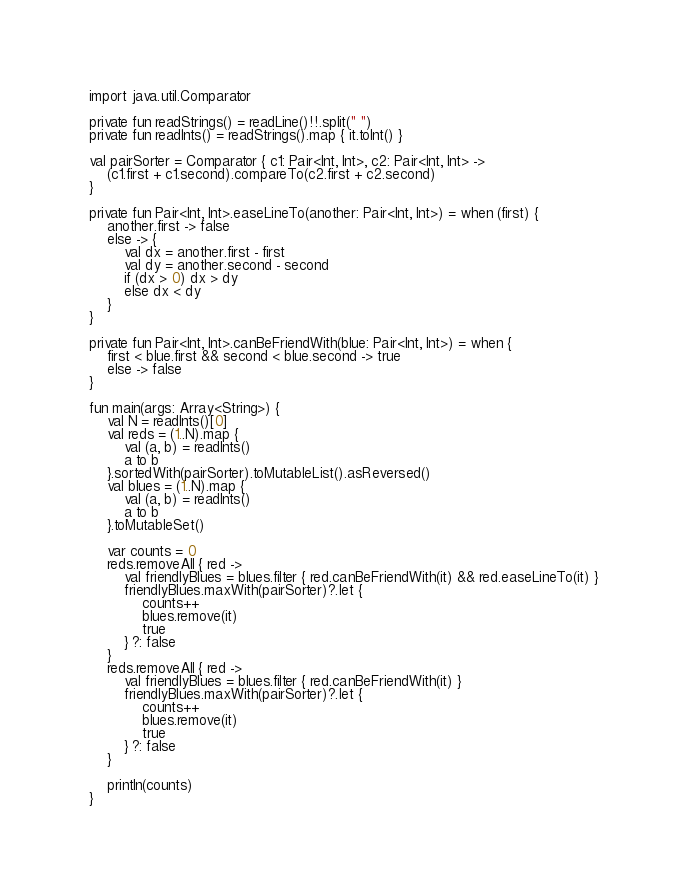Convert code to text. <code><loc_0><loc_0><loc_500><loc_500><_Kotlin_>import java.util.Comparator

private fun readStrings() = readLine()!!.split(" ")
private fun readInts() = readStrings().map { it.toInt() }

val pairSorter = Comparator { c1: Pair<Int, Int>, c2: Pair<Int, Int> ->
    (c1.first + c1.second).compareTo(c2.first + c2.second)
}

private fun Pair<Int, Int>.easeLineTo(another: Pair<Int, Int>) = when (first) {
    another.first -> false
    else -> {
        val dx = another.first - first
        val dy = another.second - second
        if (dx > 0) dx > dy
        else dx < dy
    }
}

private fun Pair<Int, Int>.canBeFriendWith(blue: Pair<Int, Int>) = when {
    first < blue.first && second < blue.second -> true
    else -> false
}

fun main(args: Array<String>) {
    val N = readInts()[0]
    val reds = (1..N).map {
        val (a, b) = readInts()
        a to b
    }.sortedWith(pairSorter).toMutableList().asReversed()
    val blues = (1..N).map {
        val (a, b) = readInts()
        a to b
    }.toMutableSet()

    var counts = 0
    reds.removeAll { red ->
        val friendlyBlues = blues.filter { red.canBeFriendWith(it) && red.easeLineTo(it) }
        friendlyBlues.maxWith(pairSorter)?.let {
            counts++
            blues.remove(it)
            true
        } ?: false
    }
    reds.removeAll { red ->
        val friendlyBlues = blues.filter { red.canBeFriendWith(it) }
        friendlyBlues.maxWith(pairSorter)?.let {
            counts++
            blues.remove(it)
            true
        } ?: false
    }

    println(counts)
}</code> 